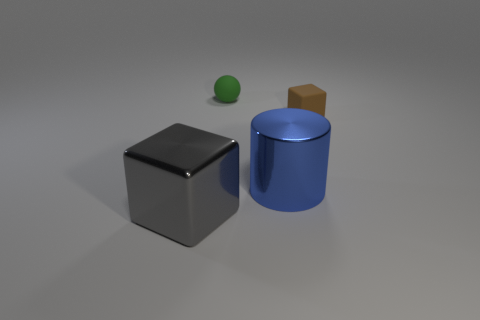What color is the block behind the big object in front of the shiny object behind the gray metal thing?
Your answer should be very brief. Brown. There is another big object that is the same shape as the brown rubber thing; what is its color?
Offer a very short reply. Gray. How big is the gray block?
Your answer should be very brief. Large. Are there any large gray things that have the same shape as the brown rubber object?
Your answer should be very brief. Yes. How many things are small green things or objects that are in front of the tiny sphere?
Give a very brief answer. 4. There is a big shiny object in front of the blue cylinder; what color is it?
Ensure brevity in your answer.  Gray. Do the green thing on the left side of the big metal cylinder and the metal block to the left of the tiny green thing have the same size?
Provide a succinct answer. No. Is there a brown cube that has the same size as the green sphere?
Your response must be concise. Yes. What number of rubber cubes are on the right side of the brown object behind the big blue metallic thing?
Your answer should be compact. 0. What is the material of the green object?
Provide a succinct answer. Rubber. 